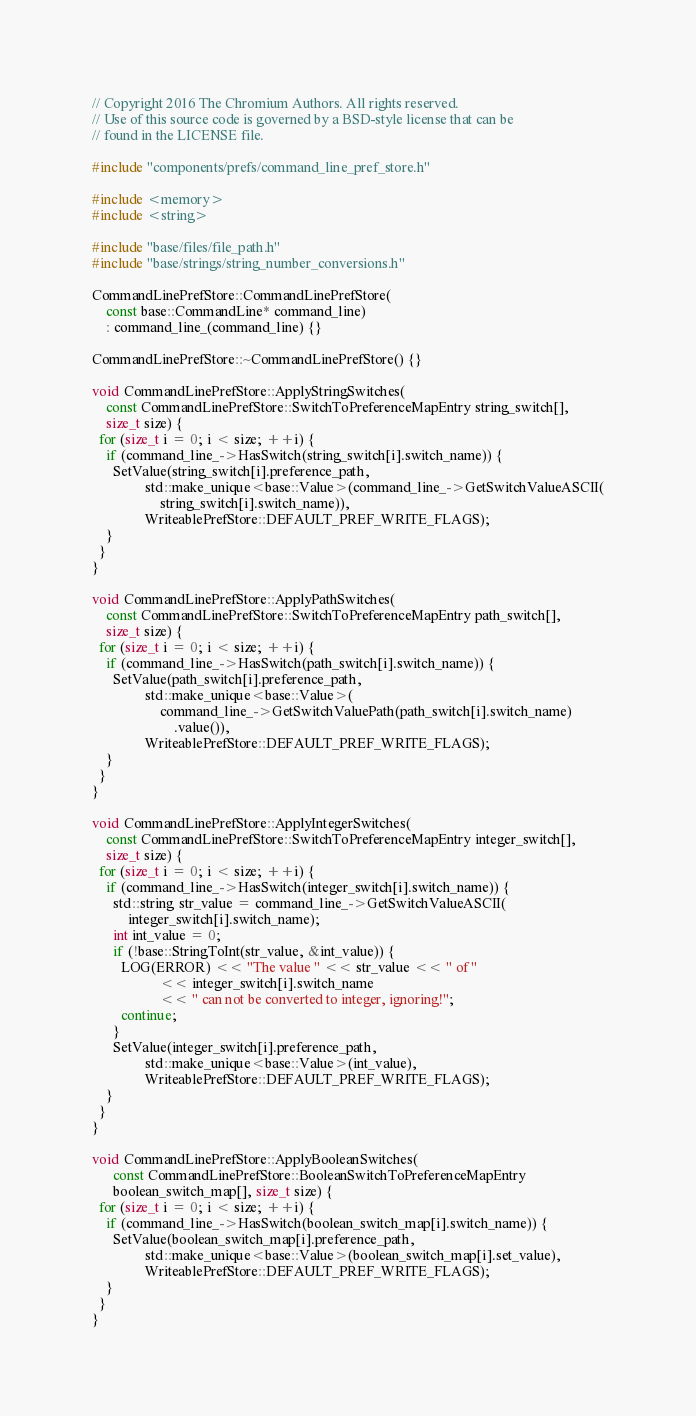<code> <loc_0><loc_0><loc_500><loc_500><_C++_>// Copyright 2016 The Chromium Authors. All rights reserved.
// Use of this source code is governed by a BSD-style license that can be
// found in the LICENSE file.

#include "components/prefs/command_line_pref_store.h"

#include <memory>
#include <string>

#include "base/files/file_path.h"
#include "base/strings/string_number_conversions.h"

CommandLinePrefStore::CommandLinePrefStore(
    const base::CommandLine* command_line)
    : command_line_(command_line) {}

CommandLinePrefStore::~CommandLinePrefStore() {}

void CommandLinePrefStore::ApplyStringSwitches(
    const CommandLinePrefStore::SwitchToPreferenceMapEntry string_switch[],
    size_t size) {
  for (size_t i = 0; i < size; ++i) {
    if (command_line_->HasSwitch(string_switch[i].switch_name)) {
      SetValue(string_switch[i].preference_path,
               std::make_unique<base::Value>(command_line_->GetSwitchValueASCII(
                   string_switch[i].switch_name)),
               WriteablePrefStore::DEFAULT_PREF_WRITE_FLAGS);
    }
  }
}

void CommandLinePrefStore::ApplyPathSwitches(
    const CommandLinePrefStore::SwitchToPreferenceMapEntry path_switch[],
    size_t size) {
  for (size_t i = 0; i < size; ++i) {
    if (command_line_->HasSwitch(path_switch[i].switch_name)) {
      SetValue(path_switch[i].preference_path,
               std::make_unique<base::Value>(
                   command_line_->GetSwitchValuePath(path_switch[i].switch_name)
                       .value()),
               WriteablePrefStore::DEFAULT_PREF_WRITE_FLAGS);
    }
  }
}

void CommandLinePrefStore::ApplyIntegerSwitches(
    const CommandLinePrefStore::SwitchToPreferenceMapEntry integer_switch[],
    size_t size) {
  for (size_t i = 0; i < size; ++i) {
    if (command_line_->HasSwitch(integer_switch[i].switch_name)) {
      std::string str_value = command_line_->GetSwitchValueASCII(
          integer_switch[i].switch_name);
      int int_value = 0;
      if (!base::StringToInt(str_value, &int_value)) {
        LOG(ERROR) << "The value " << str_value << " of "
                   << integer_switch[i].switch_name
                   << " can not be converted to integer, ignoring!";
        continue;
      }
      SetValue(integer_switch[i].preference_path,
               std::make_unique<base::Value>(int_value),
               WriteablePrefStore::DEFAULT_PREF_WRITE_FLAGS);
    }
  }
}

void CommandLinePrefStore::ApplyBooleanSwitches(
      const CommandLinePrefStore::BooleanSwitchToPreferenceMapEntry
      boolean_switch_map[], size_t size) {
  for (size_t i = 0; i < size; ++i) {
    if (command_line_->HasSwitch(boolean_switch_map[i].switch_name)) {
      SetValue(boolean_switch_map[i].preference_path,
               std::make_unique<base::Value>(boolean_switch_map[i].set_value),
               WriteablePrefStore::DEFAULT_PREF_WRITE_FLAGS);
    }
  }
}
</code> 